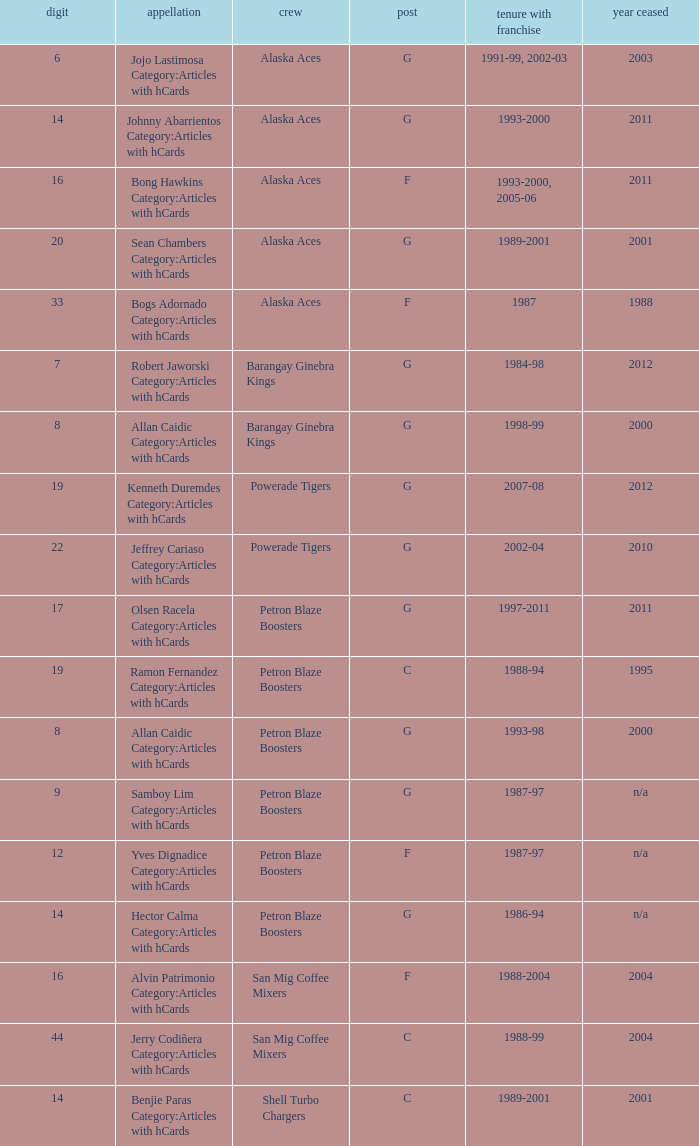How many years did the team in slot number 9 have a franchise? 1987-97. 